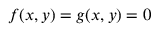<formula> <loc_0><loc_0><loc_500><loc_500>f ( x , y ) = g ( x , y ) = 0</formula> 